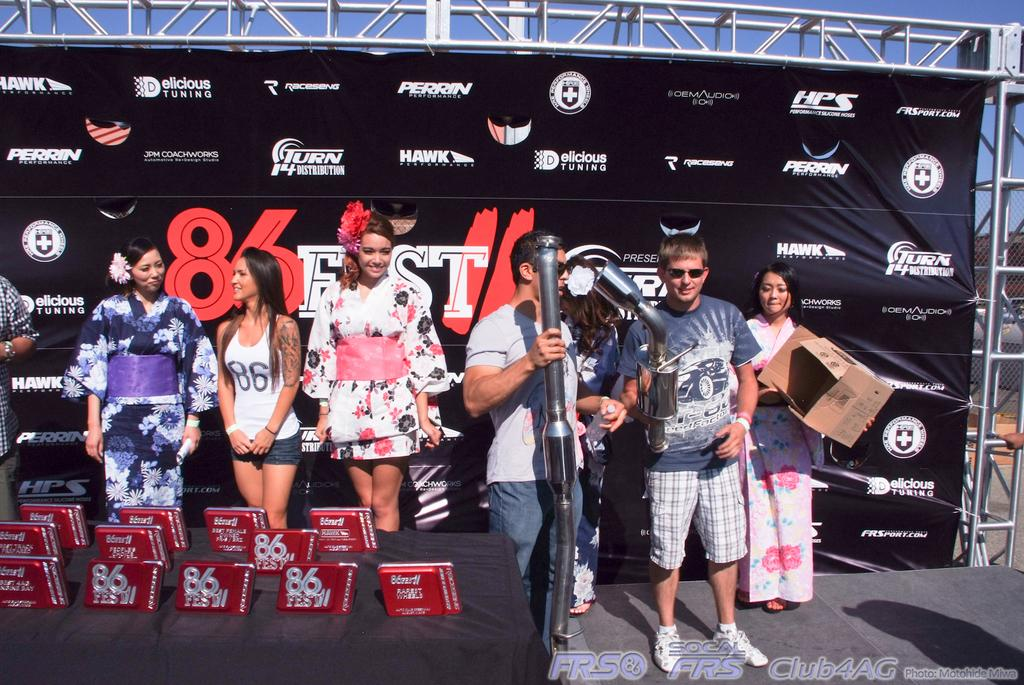<image>
Give a short and clear explanation of the subsequent image. A group of people two of which hold mufflers are on stage at the 86 Fest. 